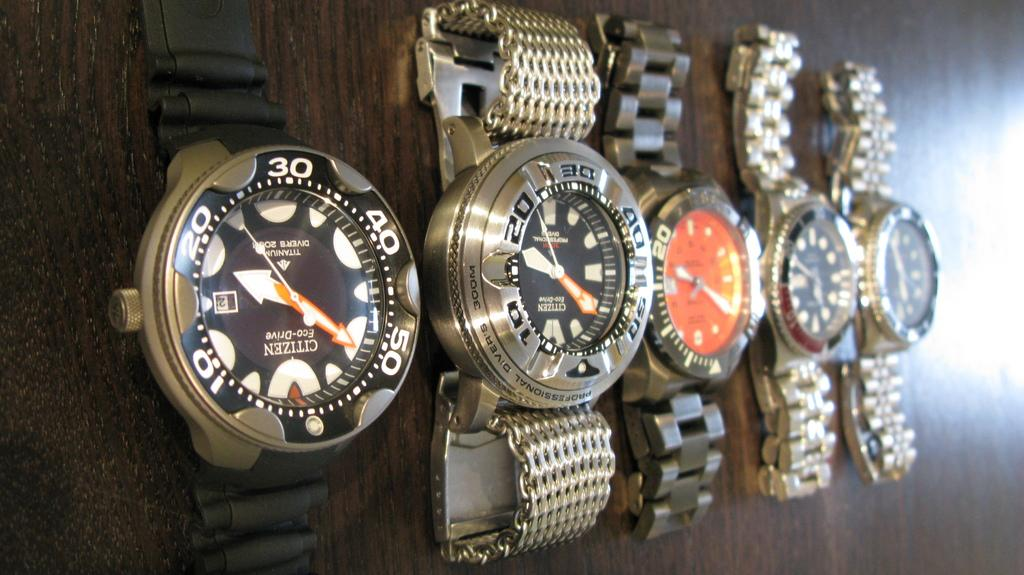<image>
Provide a brief description of the given image. A group of Citizen brand watches hang on a wall next to one another. 